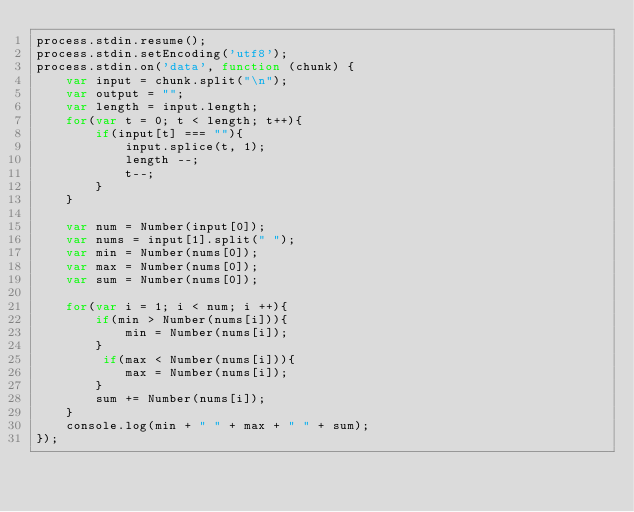<code> <loc_0><loc_0><loc_500><loc_500><_JavaScript_>process.stdin.resume();
process.stdin.setEncoding('utf8');
process.stdin.on('data', function (chunk) {
    var input = chunk.split("\n");
    var output = "";
    var length = input.length;
    for(var t = 0; t < length; t++){
        if(input[t] === ""){
            input.splice(t, 1);
            length --;
            t--;
        }
    }
    
    var num = Number(input[0]);
    var nums = input[1].split(" ");
    var min = Number(nums[0]);
    var max = Number(nums[0]);
    var sum = Number(nums[0]);
    
    for(var i = 1; i < num; i ++){
        if(min > Number(nums[i])){
            min = Number(nums[i]);
        }
         if(max < Number(nums[i])){
            max = Number(nums[i]);
        }
        sum += Number(nums[i]);
    }
    console.log(min + " " + max + " " + sum);
});</code> 